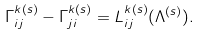<formula> <loc_0><loc_0><loc_500><loc_500>\Gamma ^ { k ( s ) } _ { i j } - \Gamma ^ { k ( s ) } _ { j i } = L ^ { k ( s ) } _ { i j } ( \Lambda ^ { ( s ) } ) .</formula> 